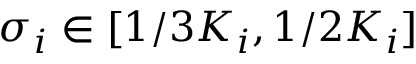<formula> <loc_0><loc_0><loc_500><loc_500>\sigma _ { i } \in [ 1 / 3 K _ { i } , 1 / 2 K _ { i } ]</formula> 